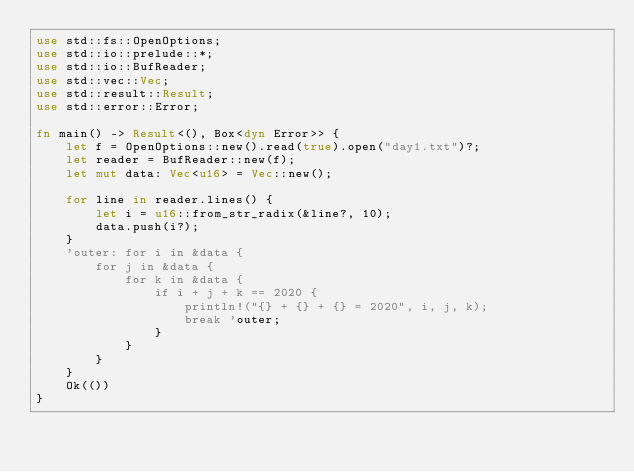Convert code to text. <code><loc_0><loc_0><loc_500><loc_500><_Rust_>use std::fs::OpenOptions;
use std::io::prelude::*;
use std::io::BufReader;
use std::vec::Vec;
use std::result::Result;
use std::error::Error;

fn main() -> Result<(), Box<dyn Error>> {
	let f = OpenOptions::new().read(true).open("day1.txt")?;
	let reader = BufReader::new(f);
	let mut data: Vec<u16> = Vec::new();

	for line in reader.lines() {
		let i = u16::from_str_radix(&line?, 10);
		data.push(i?);
	}
	'outer: for i in &data {
		for j in &data {
			for k in &data {
				if i + j + k == 2020 {
					println!("{} + {} + {} = 2020", i, j, k);
					break 'outer;
				}
			}
		}
	}
	Ok(())
}</code> 